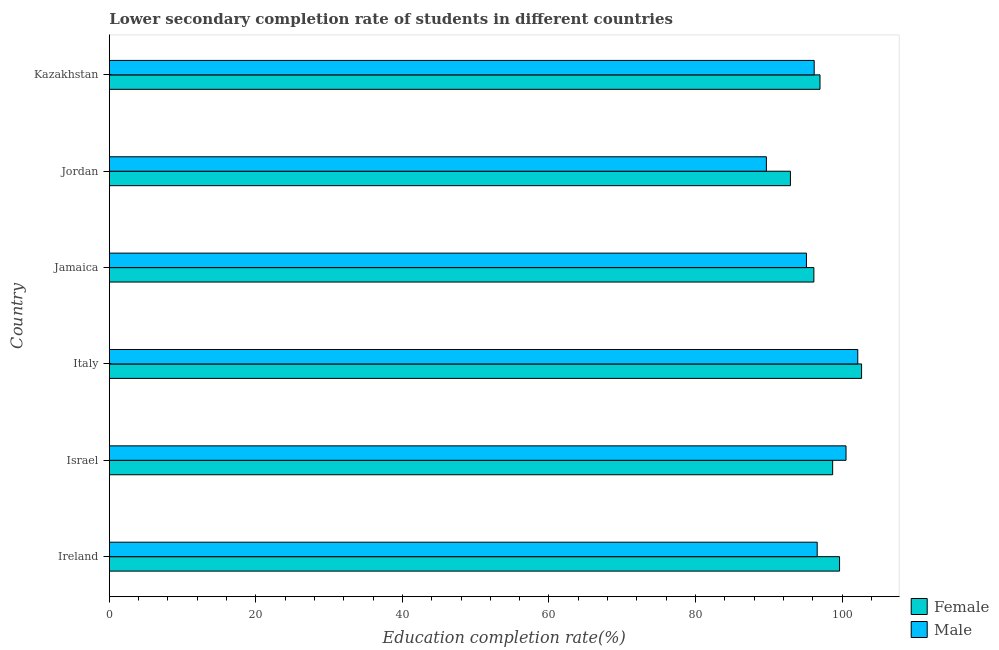How many different coloured bars are there?
Provide a short and direct response. 2. Are the number of bars per tick equal to the number of legend labels?
Provide a succinct answer. Yes. Are the number of bars on each tick of the Y-axis equal?
Provide a succinct answer. Yes. How many bars are there on the 2nd tick from the top?
Your response must be concise. 2. What is the label of the 2nd group of bars from the top?
Offer a terse response. Jordan. In how many cases, is the number of bars for a given country not equal to the number of legend labels?
Your response must be concise. 0. What is the education completion rate of female students in Ireland?
Ensure brevity in your answer.  99.65. Across all countries, what is the maximum education completion rate of male students?
Your answer should be very brief. 102.14. Across all countries, what is the minimum education completion rate of female students?
Your response must be concise. 92.95. In which country was the education completion rate of female students minimum?
Your response must be concise. Jordan. What is the total education completion rate of female students in the graph?
Offer a terse response. 587.1. What is the difference between the education completion rate of female students in Israel and that in Jamaica?
Offer a terse response. 2.56. What is the difference between the education completion rate of male students in Ireland and the education completion rate of female students in Italy?
Offer a terse response. -6.06. What is the average education completion rate of male students per country?
Give a very brief answer. 96.71. What is the difference between the education completion rate of male students and education completion rate of female students in Jamaica?
Your response must be concise. -1.01. What is the ratio of the education completion rate of female students in Jamaica to that in Kazakhstan?
Offer a terse response. 0.99. Is the difference between the education completion rate of female students in Ireland and Jamaica greater than the difference between the education completion rate of male students in Ireland and Jamaica?
Give a very brief answer. Yes. What is the difference between the highest and the second highest education completion rate of male students?
Keep it short and to the point. 1.6. What is the difference between the highest and the lowest education completion rate of male students?
Your answer should be compact. 12.47. In how many countries, is the education completion rate of male students greater than the average education completion rate of male students taken over all countries?
Offer a terse response. 2. What does the 2nd bar from the top in Israel represents?
Give a very brief answer. Female. Are all the bars in the graph horizontal?
Ensure brevity in your answer.  Yes. What is the difference between two consecutive major ticks on the X-axis?
Provide a short and direct response. 20. Are the values on the major ticks of X-axis written in scientific E-notation?
Provide a succinct answer. No. Does the graph contain any zero values?
Provide a succinct answer. No. How many legend labels are there?
Provide a succinct answer. 2. How are the legend labels stacked?
Give a very brief answer. Vertical. What is the title of the graph?
Your answer should be very brief. Lower secondary completion rate of students in different countries. What is the label or title of the X-axis?
Your response must be concise. Education completion rate(%). What is the label or title of the Y-axis?
Provide a short and direct response. Country. What is the Education completion rate(%) in Female in Ireland?
Keep it short and to the point. 99.65. What is the Education completion rate(%) of Male in Ireland?
Ensure brevity in your answer.  96.6. What is the Education completion rate(%) in Female in Israel?
Your answer should be compact. 98.71. What is the Education completion rate(%) in Male in Israel?
Provide a short and direct response. 100.54. What is the Education completion rate(%) of Female in Italy?
Your response must be concise. 102.66. What is the Education completion rate(%) of Male in Italy?
Offer a terse response. 102.14. What is the Education completion rate(%) of Female in Jamaica?
Give a very brief answer. 96.15. What is the Education completion rate(%) of Male in Jamaica?
Your answer should be compact. 95.13. What is the Education completion rate(%) in Female in Jordan?
Offer a very short reply. 92.95. What is the Education completion rate(%) of Male in Jordan?
Keep it short and to the point. 89.67. What is the Education completion rate(%) in Female in Kazakhstan?
Keep it short and to the point. 96.98. What is the Education completion rate(%) in Male in Kazakhstan?
Keep it short and to the point. 96.19. Across all countries, what is the maximum Education completion rate(%) in Female?
Provide a succinct answer. 102.66. Across all countries, what is the maximum Education completion rate(%) in Male?
Your answer should be very brief. 102.14. Across all countries, what is the minimum Education completion rate(%) in Female?
Offer a very short reply. 92.95. Across all countries, what is the minimum Education completion rate(%) of Male?
Your answer should be very brief. 89.67. What is the total Education completion rate(%) in Female in the graph?
Ensure brevity in your answer.  587.1. What is the total Education completion rate(%) in Male in the graph?
Offer a very short reply. 580.26. What is the difference between the Education completion rate(%) in Female in Ireland and that in Israel?
Provide a succinct answer. 0.94. What is the difference between the Education completion rate(%) of Male in Ireland and that in Israel?
Make the answer very short. -3.93. What is the difference between the Education completion rate(%) in Female in Ireland and that in Italy?
Your response must be concise. -3.01. What is the difference between the Education completion rate(%) of Male in Ireland and that in Italy?
Make the answer very short. -5.54. What is the difference between the Education completion rate(%) in Female in Ireland and that in Jamaica?
Make the answer very short. 3.5. What is the difference between the Education completion rate(%) in Male in Ireland and that in Jamaica?
Your answer should be very brief. 1.47. What is the difference between the Education completion rate(%) in Female in Ireland and that in Jordan?
Provide a short and direct response. 6.7. What is the difference between the Education completion rate(%) in Male in Ireland and that in Jordan?
Offer a terse response. 6.94. What is the difference between the Education completion rate(%) of Female in Ireland and that in Kazakhstan?
Your answer should be very brief. 2.67. What is the difference between the Education completion rate(%) of Male in Ireland and that in Kazakhstan?
Make the answer very short. 0.41. What is the difference between the Education completion rate(%) in Female in Israel and that in Italy?
Make the answer very short. -3.95. What is the difference between the Education completion rate(%) of Male in Israel and that in Italy?
Offer a very short reply. -1.6. What is the difference between the Education completion rate(%) of Female in Israel and that in Jamaica?
Your answer should be compact. 2.56. What is the difference between the Education completion rate(%) of Male in Israel and that in Jamaica?
Give a very brief answer. 5.4. What is the difference between the Education completion rate(%) of Female in Israel and that in Jordan?
Make the answer very short. 5.76. What is the difference between the Education completion rate(%) of Male in Israel and that in Jordan?
Ensure brevity in your answer.  10.87. What is the difference between the Education completion rate(%) in Female in Israel and that in Kazakhstan?
Ensure brevity in your answer.  1.73. What is the difference between the Education completion rate(%) of Male in Israel and that in Kazakhstan?
Provide a succinct answer. 4.35. What is the difference between the Education completion rate(%) in Female in Italy and that in Jamaica?
Offer a very short reply. 6.51. What is the difference between the Education completion rate(%) in Male in Italy and that in Jamaica?
Your answer should be compact. 7. What is the difference between the Education completion rate(%) of Female in Italy and that in Jordan?
Make the answer very short. 9.71. What is the difference between the Education completion rate(%) of Male in Italy and that in Jordan?
Your answer should be very brief. 12.47. What is the difference between the Education completion rate(%) of Female in Italy and that in Kazakhstan?
Offer a very short reply. 5.67. What is the difference between the Education completion rate(%) of Male in Italy and that in Kazakhstan?
Your answer should be very brief. 5.95. What is the difference between the Education completion rate(%) in Female in Jamaica and that in Jordan?
Give a very brief answer. 3.2. What is the difference between the Education completion rate(%) in Male in Jamaica and that in Jordan?
Keep it short and to the point. 5.47. What is the difference between the Education completion rate(%) in Female in Jamaica and that in Kazakhstan?
Your answer should be compact. -0.84. What is the difference between the Education completion rate(%) in Male in Jamaica and that in Kazakhstan?
Offer a terse response. -1.06. What is the difference between the Education completion rate(%) of Female in Jordan and that in Kazakhstan?
Offer a very short reply. -4.04. What is the difference between the Education completion rate(%) of Male in Jordan and that in Kazakhstan?
Offer a very short reply. -6.52. What is the difference between the Education completion rate(%) of Female in Ireland and the Education completion rate(%) of Male in Israel?
Give a very brief answer. -0.88. What is the difference between the Education completion rate(%) in Female in Ireland and the Education completion rate(%) in Male in Italy?
Your response must be concise. -2.48. What is the difference between the Education completion rate(%) of Female in Ireland and the Education completion rate(%) of Male in Jamaica?
Ensure brevity in your answer.  4.52. What is the difference between the Education completion rate(%) in Female in Ireland and the Education completion rate(%) in Male in Jordan?
Your answer should be compact. 9.99. What is the difference between the Education completion rate(%) in Female in Ireland and the Education completion rate(%) in Male in Kazakhstan?
Ensure brevity in your answer.  3.46. What is the difference between the Education completion rate(%) in Female in Israel and the Education completion rate(%) in Male in Italy?
Your response must be concise. -3.43. What is the difference between the Education completion rate(%) of Female in Israel and the Education completion rate(%) of Male in Jamaica?
Provide a short and direct response. 3.58. What is the difference between the Education completion rate(%) in Female in Israel and the Education completion rate(%) in Male in Jordan?
Give a very brief answer. 9.05. What is the difference between the Education completion rate(%) of Female in Israel and the Education completion rate(%) of Male in Kazakhstan?
Make the answer very short. 2.52. What is the difference between the Education completion rate(%) in Female in Italy and the Education completion rate(%) in Male in Jamaica?
Your answer should be very brief. 7.52. What is the difference between the Education completion rate(%) in Female in Italy and the Education completion rate(%) in Male in Jordan?
Ensure brevity in your answer.  12.99. What is the difference between the Education completion rate(%) of Female in Italy and the Education completion rate(%) of Male in Kazakhstan?
Make the answer very short. 6.47. What is the difference between the Education completion rate(%) in Female in Jamaica and the Education completion rate(%) in Male in Jordan?
Your answer should be very brief. 6.48. What is the difference between the Education completion rate(%) in Female in Jamaica and the Education completion rate(%) in Male in Kazakhstan?
Make the answer very short. -0.04. What is the difference between the Education completion rate(%) of Female in Jordan and the Education completion rate(%) of Male in Kazakhstan?
Make the answer very short. -3.24. What is the average Education completion rate(%) in Female per country?
Keep it short and to the point. 97.85. What is the average Education completion rate(%) of Male per country?
Give a very brief answer. 96.71. What is the difference between the Education completion rate(%) in Female and Education completion rate(%) in Male in Ireland?
Offer a very short reply. 3.05. What is the difference between the Education completion rate(%) in Female and Education completion rate(%) in Male in Israel?
Your answer should be compact. -1.82. What is the difference between the Education completion rate(%) in Female and Education completion rate(%) in Male in Italy?
Make the answer very short. 0.52. What is the difference between the Education completion rate(%) of Female and Education completion rate(%) of Male in Jamaica?
Offer a terse response. 1.01. What is the difference between the Education completion rate(%) of Female and Education completion rate(%) of Male in Jordan?
Offer a terse response. 3.28. What is the difference between the Education completion rate(%) of Female and Education completion rate(%) of Male in Kazakhstan?
Your answer should be compact. 0.79. What is the ratio of the Education completion rate(%) of Female in Ireland to that in Israel?
Give a very brief answer. 1.01. What is the ratio of the Education completion rate(%) of Male in Ireland to that in Israel?
Ensure brevity in your answer.  0.96. What is the ratio of the Education completion rate(%) of Female in Ireland to that in Italy?
Provide a succinct answer. 0.97. What is the ratio of the Education completion rate(%) in Male in Ireland to that in Italy?
Offer a very short reply. 0.95. What is the ratio of the Education completion rate(%) in Female in Ireland to that in Jamaica?
Your response must be concise. 1.04. What is the ratio of the Education completion rate(%) of Male in Ireland to that in Jamaica?
Ensure brevity in your answer.  1.02. What is the ratio of the Education completion rate(%) in Female in Ireland to that in Jordan?
Give a very brief answer. 1.07. What is the ratio of the Education completion rate(%) in Male in Ireland to that in Jordan?
Give a very brief answer. 1.08. What is the ratio of the Education completion rate(%) in Female in Ireland to that in Kazakhstan?
Your answer should be very brief. 1.03. What is the ratio of the Education completion rate(%) in Male in Ireland to that in Kazakhstan?
Provide a succinct answer. 1. What is the ratio of the Education completion rate(%) in Female in Israel to that in Italy?
Your response must be concise. 0.96. What is the ratio of the Education completion rate(%) of Male in Israel to that in Italy?
Offer a terse response. 0.98. What is the ratio of the Education completion rate(%) in Female in Israel to that in Jamaica?
Offer a terse response. 1.03. What is the ratio of the Education completion rate(%) in Male in Israel to that in Jamaica?
Your answer should be compact. 1.06. What is the ratio of the Education completion rate(%) in Female in Israel to that in Jordan?
Your answer should be compact. 1.06. What is the ratio of the Education completion rate(%) in Male in Israel to that in Jordan?
Keep it short and to the point. 1.12. What is the ratio of the Education completion rate(%) of Female in Israel to that in Kazakhstan?
Provide a short and direct response. 1.02. What is the ratio of the Education completion rate(%) in Male in Israel to that in Kazakhstan?
Give a very brief answer. 1.05. What is the ratio of the Education completion rate(%) in Female in Italy to that in Jamaica?
Offer a very short reply. 1.07. What is the ratio of the Education completion rate(%) of Male in Italy to that in Jamaica?
Provide a succinct answer. 1.07. What is the ratio of the Education completion rate(%) in Female in Italy to that in Jordan?
Your answer should be compact. 1.1. What is the ratio of the Education completion rate(%) in Male in Italy to that in Jordan?
Provide a short and direct response. 1.14. What is the ratio of the Education completion rate(%) of Female in Italy to that in Kazakhstan?
Your answer should be compact. 1.06. What is the ratio of the Education completion rate(%) in Male in Italy to that in Kazakhstan?
Your answer should be very brief. 1.06. What is the ratio of the Education completion rate(%) in Female in Jamaica to that in Jordan?
Give a very brief answer. 1.03. What is the ratio of the Education completion rate(%) in Male in Jamaica to that in Jordan?
Provide a short and direct response. 1.06. What is the ratio of the Education completion rate(%) in Female in Jamaica to that in Kazakhstan?
Keep it short and to the point. 0.99. What is the ratio of the Education completion rate(%) in Male in Jamaica to that in Kazakhstan?
Offer a terse response. 0.99. What is the ratio of the Education completion rate(%) in Female in Jordan to that in Kazakhstan?
Make the answer very short. 0.96. What is the ratio of the Education completion rate(%) in Male in Jordan to that in Kazakhstan?
Offer a very short reply. 0.93. What is the difference between the highest and the second highest Education completion rate(%) of Female?
Provide a succinct answer. 3.01. What is the difference between the highest and the second highest Education completion rate(%) in Male?
Your answer should be very brief. 1.6. What is the difference between the highest and the lowest Education completion rate(%) of Female?
Your answer should be compact. 9.71. What is the difference between the highest and the lowest Education completion rate(%) of Male?
Your answer should be very brief. 12.47. 